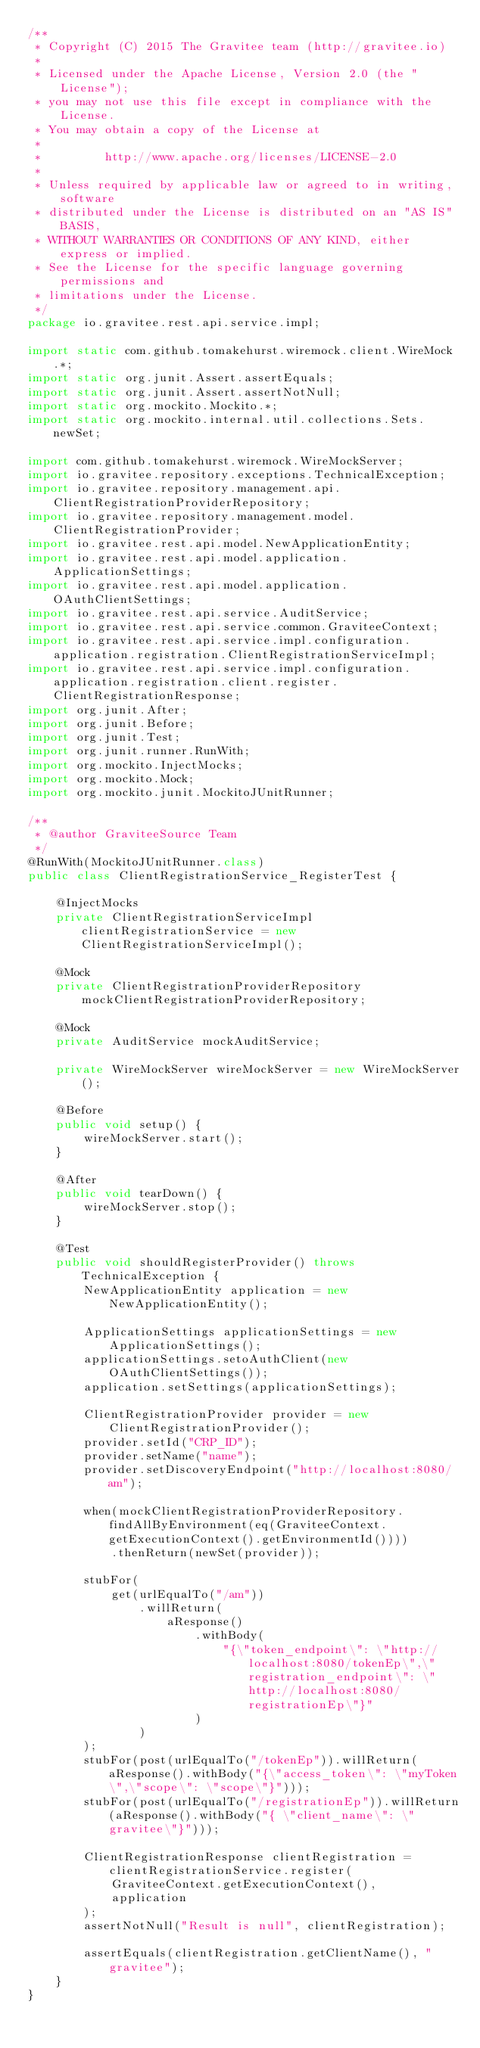Convert code to text. <code><loc_0><loc_0><loc_500><loc_500><_Java_>/**
 * Copyright (C) 2015 The Gravitee team (http://gravitee.io)
 *
 * Licensed under the Apache License, Version 2.0 (the "License");
 * you may not use this file except in compliance with the License.
 * You may obtain a copy of the License at
 *
 *         http://www.apache.org/licenses/LICENSE-2.0
 *
 * Unless required by applicable law or agreed to in writing, software
 * distributed under the License is distributed on an "AS IS" BASIS,
 * WITHOUT WARRANTIES OR CONDITIONS OF ANY KIND, either express or implied.
 * See the License for the specific language governing permissions and
 * limitations under the License.
 */
package io.gravitee.rest.api.service.impl;

import static com.github.tomakehurst.wiremock.client.WireMock.*;
import static org.junit.Assert.assertEquals;
import static org.junit.Assert.assertNotNull;
import static org.mockito.Mockito.*;
import static org.mockito.internal.util.collections.Sets.newSet;

import com.github.tomakehurst.wiremock.WireMockServer;
import io.gravitee.repository.exceptions.TechnicalException;
import io.gravitee.repository.management.api.ClientRegistrationProviderRepository;
import io.gravitee.repository.management.model.ClientRegistrationProvider;
import io.gravitee.rest.api.model.NewApplicationEntity;
import io.gravitee.rest.api.model.application.ApplicationSettings;
import io.gravitee.rest.api.model.application.OAuthClientSettings;
import io.gravitee.rest.api.service.AuditService;
import io.gravitee.rest.api.service.common.GraviteeContext;
import io.gravitee.rest.api.service.impl.configuration.application.registration.ClientRegistrationServiceImpl;
import io.gravitee.rest.api.service.impl.configuration.application.registration.client.register.ClientRegistrationResponse;
import org.junit.After;
import org.junit.Before;
import org.junit.Test;
import org.junit.runner.RunWith;
import org.mockito.InjectMocks;
import org.mockito.Mock;
import org.mockito.junit.MockitoJUnitRunner;

/**
 * @author GraviteeSource Team
 */
@RunWith(MockitoJUnitRunner.class)
public class ClientRegistrationService_RegisterTest {

    @InjectMocks
    private ClientRegistrationServiceImpl clientRegistrationService = new ClientRegistrationServiceImpl();

    @Mock
    private ClientRegistrationProviderRepository mockClientRegistrationProviderRepository;

    @Mock
    private AuditService mockAuditService;

    private WireMockServer wireMockServer = new WireMockServer();

    @Before
    public void setup() {
        wireMockServer.start();
    }

    @After
    public void tearDown() {
        wireMockServer.stop();
    }

    @Test
    public void shouldRegisterProvider() throws TechnicalException {
        NewApplicationEntity application = new NewApplicationEntity();

        ApplicationSettings applicationSettings = new ApplicationSettings();
        applicationSettings.setoAuthClient(new OAuthClientSettings());
        application.setSettings(applicationSettings);

        ClientRegistrationProvider provider = new ClientRegistrationProvider();
        provider.setId("CRP_ID");
        provider.setName("name");
        provider.setDiscoveryEndpoint("http://localhost:8080/am");

        when(mockClientRegistrationProviderRepository.findAllByEnvironment(eq(GraviteeContext.getExecutionContext().getEnvironmentId())))
            .thenReturn(newSet(provider));

        stubFor(
            get(urlEqualTo("/am"))
                .willReturn(
                    aResponse()
                        .withBody(
                            "{\"token_endpoint\": \"http://localhost:8080/tokenEp\",\"registration_endpoint\": \"http://localhost:8080/registrationEp\"}"
                        )
                )
        );
        stubFor(post(urlEqualTo("/tokenEp")).willReturn(aResponse().withBody("{\"access_token\": \"myToken\",\"scope\": \"scope\"}")));
        stubFor(post(urlEqualTo("/registrationEp")).willReturn(aResponse().withBody("{ \"client_name\": \"gravitee\"}")));

        ClientRegistrationResponse clientRegistration = clientRegistrationService.register(
            GraviteeContext.getExecutionContext(),
            application
        );
        assertNotNull("Result is null", clientRegistration);

        assertEquals(clientRegistration.getClientName(), "gravitee");
    }
}
</code> 